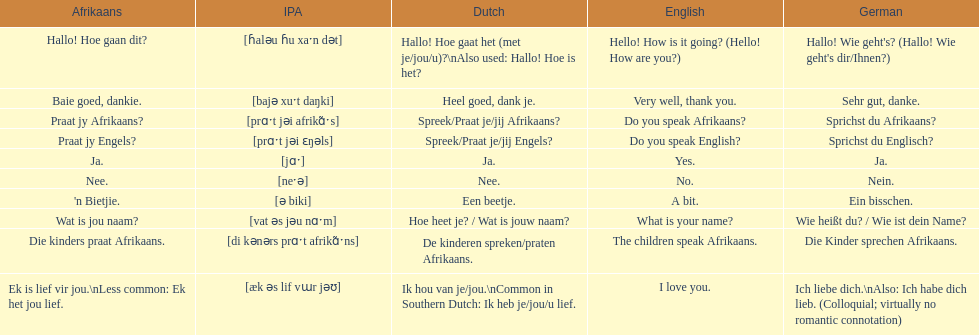How do you say 'yes' in afrikaans? Ja. 